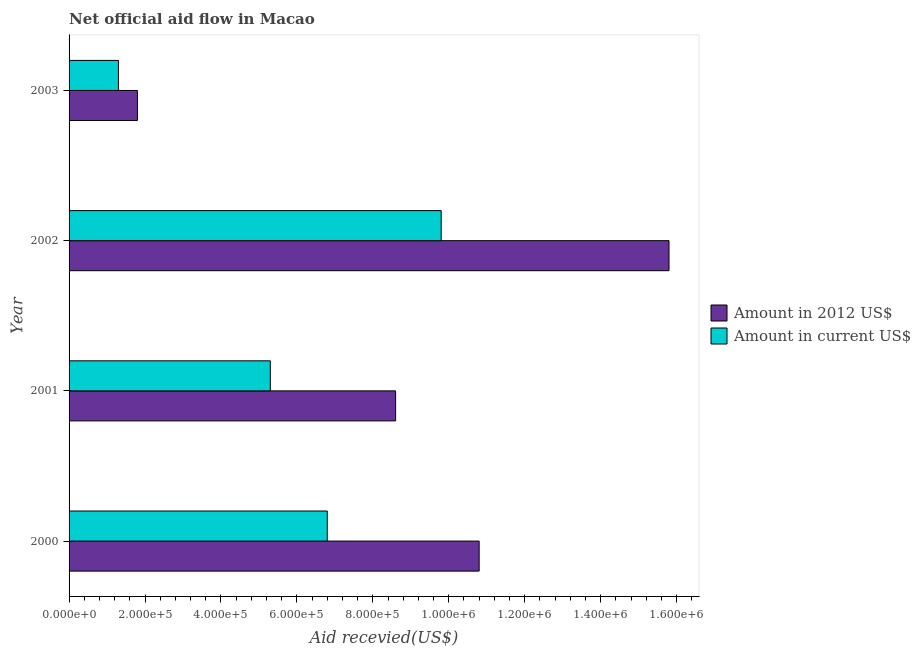How many groups of bars are there?
Give a very brief answer. 4. Are the number of bars on each tick of the Y-axis equal?
Ensure brevity in your answer.  Yes. How many bars are there on the 4th tick from the bottom?
Offer a very short reply. 2. What is the label of the 4th group of bars from the top?
Provide a succinct answer. 2000. What is the amount of aid received(expressed in us$) in 2002?
Make the answer very short. 9.80e+05. Across all years, what is the maximum amount of aid received(expressed in 2012 us$)?
Give a very brief answer. 1.58e+06. Across all years, what is the minimum amount of aid received(expressed in us$)?
Provide a succinct answer. 1.30e+05. In which year was the amount of aid received(expressed in 2012 us$) maximum?
Your response must be concise. 2002. What is the total amount of aid received(expressed in us$) in the graph?
Offer a very short reply. 2.32e+06. What is the difference between the amount of aid received(expressed in us$) in 2001 and that in 2002?
Your response must be concise. -4.50e+05. What is the difference between the amount of aid received(expressed in 2012 us$) in 2001 and the amount of aid received(expressed in us$) in 2002?
Provide a short and direct response. -1.20e+05. What is the average amount of aid received(expressed in 2012 us$) per year?
Offer a terse response. 9.25e+05. In the year 2000, what is the difference between the amount of aid received(expressed in 2012 us$) and amount of aid received(expressed in us$)?
Provide a succinct answer. 4.00e+05. In how many years, is the amount of aid received(expressed in 2012 us$) greater than 920000 US$?
Provide a short and direct response. 2. What is the ratio of the amount of aid received(expressed in us$) in 2001 to that in 2003?
Your answer should be compact. 4.08. What is the difference between the highest and the lowest amount of aid received(expressed in 2012 us$)?
Keep it short and to the point. 1.40e+06. In how many years, is the amount of aid received(expressed in 2012 us$) greater than the average amount of aid received(expressed in 2012 us$) taken over all years?
Give a very brief answer. 2. Is the sum of the amount of aid received(expressed in us$) in 2000 and 2003 greater than the maximum amount of aid received(expressed in 2012 us$) across all years?
Your response must be concise. No. What does the 1st bar from the top in 2002 represents?
Your response must be concise. Amount in current US$. What does the 1st bar from the bottom in 2000 represents?
Ensure brevity in your answer.  Amount in 2012 US$. How many bars are there?
Offer a very short reply. 8. How many years are there in the graph?
Provide a short and direct response. 4. What is the difference between two consecutive major ticks on the X-axis?
Provide a short and direct response. 2.00e+05. Are the values on the major ticks of X-axis written in scientific E-notation?
Ensure brevity in your answer.  Yes. Does the graph contain any zero values?
Ensure brevity in your answer.  No. Does the graph contain grids?
Your response must be concise. No. How many legend labels are there?
Provide a short and direct response. 2. How are the legend labels stacked?
Offer a terse response. Vertical. What is the title of the graph?
Make the answer very short. Net official aid flow in Macao. Does "Non-residents" appear as one of the legend labels in the graph?
Your answer should be compact. No. What is the label or title of the X-axis?
Keep it short and to the point. Aid recevied(US$). What is the Aid recevied(US$) of Amount in 2012 US$ in 2000?
Your response must be concise. 1.08e+06. What is the Aid recevied(US$) in Amount in current US$ in 2000?
Offer a very short reply. 6.80e+05. What is the Aid recevied(US$) of Amount in 2012 US$ in 2001?
Give a very brief answer. 8.60e+05. What is the Aid recevied(US$) in Amount in current US$ in 2001?
Provide a short and direct response. 5.30e+05. What is the Aid recevied(US$) of Amount in 2012 US$ in 2002?
Give a very brief answer. 1.58e+06. What is the Aid recevied(US$) of Amount in current US$ in 2002?
Your response must be concise. 9.80e+05. What is the Aid recevied(US$) of Amount in 2012 US$ in 2003?
Offer a very short reply. 1.80e+05. Across all years, what is the maximum Aid recevied(US$) of Amount in 2012 US$?
Your response must be concise. 1.58e+06. Across all years, what is the maximum Aid recevied(US$) of Amount in current US$?
Offer a very short reply. 9.80e+05. Across all years, what is the minimum Aid recevied(US$) of Amount in 2012 US$?
Give a very brief answer. 1.80e+05. Across all years, what is the minimum Aid recevied(US$) of Amount in current US$?
Ensure brevity in your answer.  1.30e+05. What is the total Aid recevied(US$) in Amount in 2012 US$ in the graph?
Keep it short and to the point. 3.70e+06. What is the total Aid recevied(US$) in Amount in current US$ in the graph?
Provide a succinct answer. 2.32e+06. What is the difference between the Aid recevied(US$) in Amount in 2012 US$ in 2000 and that in 2002?
Give a very brief answer. -5.00e+05. What is the difference between the Aid recevied(US$) of Amount in current US$ in 2000 and that in 2002?
Offer a terse response. -3.00e+05. What is the difference between the Aid recevied(US$) in Amount in 2012 US$ in 2000 and that in 2003?
Ensure brevity in your answer.  9.00e+05. What is the difference between the Aid recevied(US$) in Amount in current US$ in 2000 and that in 2003?
Provide a short and direct response. 5.50e+05. What is the difference between the Aid recevied(US$) in Amount in 2012 US$ in 2001 and that in 2002?
Your answer should be compact. -7.20e+05. What is the difference between the Aid recevied(US$) of Amount in current US$ in 2001 and that in 2002?
Your answer should be very brief. -4.50e+05. What is the difference between the Aid recevied(US$) of Amount in 2012 US$ in 2001 and that in 2003?
Provide a succinct answer. 6.80e+05. What is the difference between the Aid recevied(US$) in Amount in current US$ in 2001 and that in 2003?
Your answer should be very brief. 4.00e+05. What is the difference between the Aid recevied(US$) of Amount in 2012 US$ in 2002 and that in 2003?
Make the answer very short. 1.40e+06. What is the difference between the Aid recevied(US$) in Amount in current US$ in 2002 and that in 2003?
Your answer should be very brief. 8.50e+05. What is the difference between the Aid recevied(US$) in Amount in 2012 US$ in 2000 and the Aid recevied(US$) in Amount in current US$ in 2003?
Your answer should be very brief. 9.50e+05. What is the difference between the Aid recevied(US$) of Amount in 2012 US$ in 2001 and the Aid recevied(US$) of Amount in current US$ in 2003?
Make the answer very short. 7.30e+05. What is the difference between the Aid recevied(US$) in Amount in 2012 US$ in 2002 and the Aid recevied(US$) in Amount in current US$ in 2003?
Offer a terse response. 1.45e+06. What is the average Aid recevied(US$) of Amount in 2012 US$ per year?
Keep it short and to the point. 9.25e+05. What is the average Aid recevied(US$) in Amount in current US$ per year?
Your response must be concise. 5.80e+05. What is the ratio of the Aid recevied(US$) in Amount in 2012 US$ in 2000 to that in 2001?
Ensure brevity in your answer.  1.26. What is the ratio of the Aid recevied(US$) of Amount in current US$ in 2000 to that in 2001?
Keep it short and to the point. 1.28. What is the ratio of the Aid recevied(US$) in Amount in 2012 US$ in 2000 to that in 2002?
Provide a short and direct response. 0.68. What is the ratio of the Aid recevied(US$) in Amount in current US$ in 2000 to that in 2002?
Offer a terse response. 0.69. What is the ratio of the Aid recevied(US$) of Amount in current US$ in 2000 to that in 2003?
Provide a short and direct response. 5.23. What is the ratio of the Aid recevied(US$) in Amount in 2012 US$ in 2001 to that in 2002?
Keep it short and to the point. 0.54. What is the ratio of the Aid recevied(US$) of Amount in current US$ in 2001 to that in 2002?
Your answer should be very brief. 0.54. What is the ratio of the Aid recevied(US$) in Amount in 2012 US$ in 2001 to that in 2003?
Ensure brevity in your answer.  4.78. What is the ratio of the Aid recevied(US$) of Amount in current US$ in 2001 to that in 2003?
Keep it short and to the point. 4.08. What is the ratio of the Aid recevied(US$) of Amount in 2012 US$ in 2002 to that in 2003?
Give a very brief answer. 8.78. What is the ratio of the Aid recevied(US$) of Amount in current US$ in 2002 to that in 2003?
Provide a succinct answer. 7.54. What is the difference between the highest and the lowest Aid recevied(US$) in Amount in 2012 US$?
Provide a short and direct response. 1.40e+06. What is the difference between the highest and the lowest Aid recevied(US$) of Amount in current US$?
Ensure brevity in your answer.  8.50e+05. 